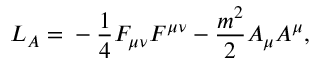Convert formula to latex. <formula><loc_0><loc_0><loc_500><loc_500>L _ { A } = - \frac { 1 } { 4 } F _ { \mu \nu } F ^ { \mu \nu } - \frac { m ^ { 2 } } { 2 } A _ { \mu } A ^ { \mu } ,</formula> 